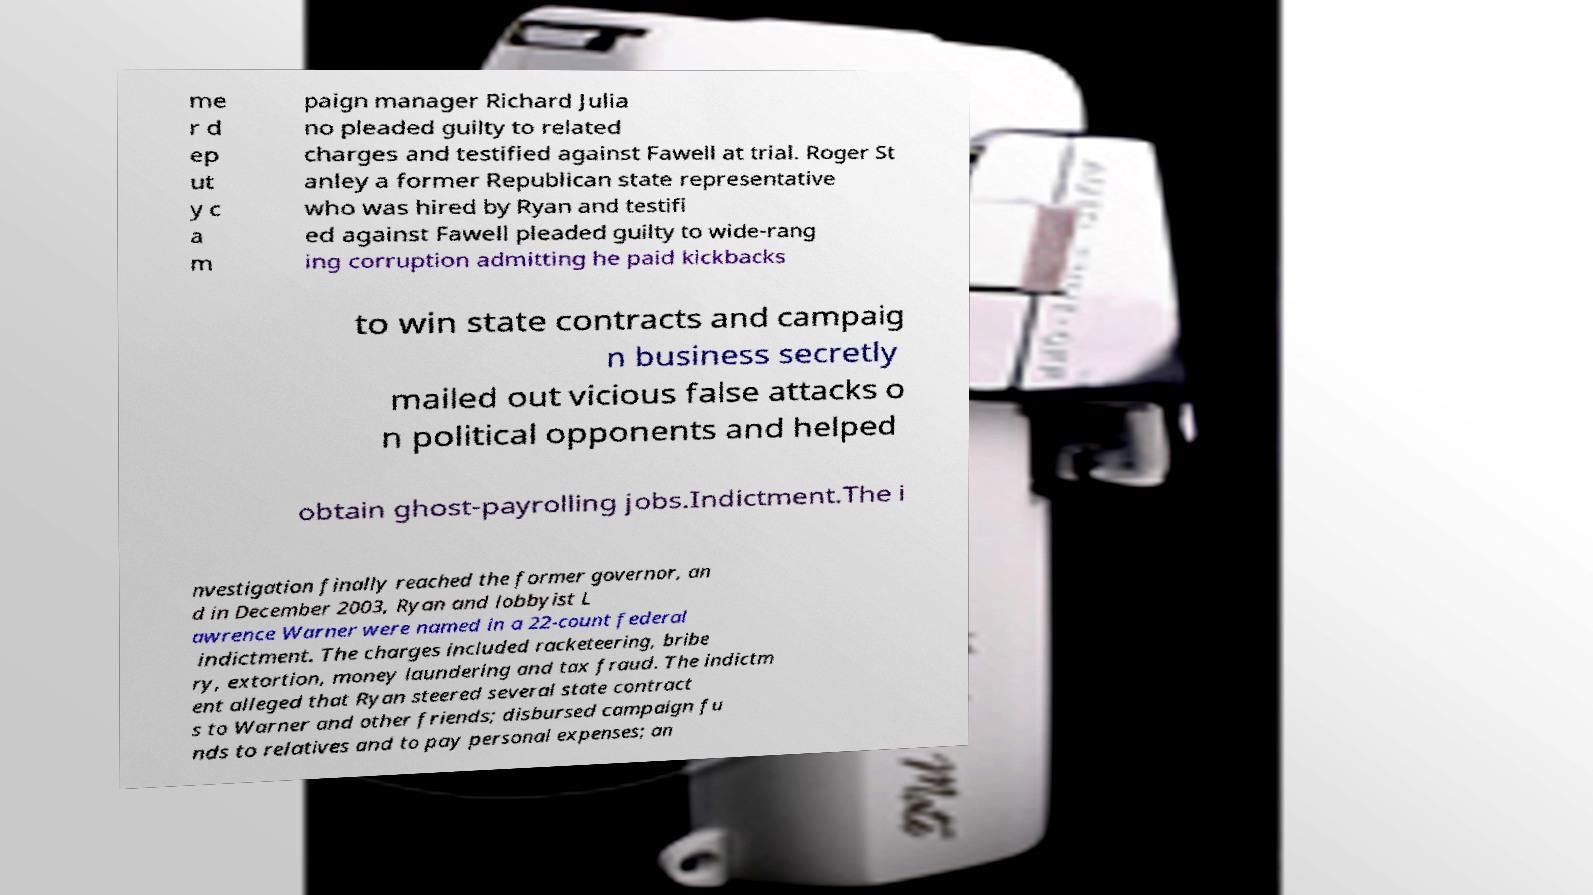Please read and relay the text visible in this image. What does it say? me r d ep ut y c a m paign manager Richard Julia no pleaded guilty to related charges and testified against Fawell at trial. Roger St anley a former Republican state representative who was hired by Ryan and testifi ed against Fawell pleaded guilty to wide-rang ing corruption admitting he paid kickbacks to win state contracts and campaig n business secretly mailed out vicious false attacks o n political opponents and helped obtain ghost-payrolling jobs.Indictment.The i nvestigation finally reached the former governor, an d in December 2003, Ryan and lobbyist L awrence Warner were named in a 22-count federal indictment. The charges included racketeering, bribe ry, extortion, money laundering and tax fraud. The indictm ent alleged that Ryan steered several state contract s to Warner and other friends; disbursed campaign fu nds to relatives and to pay personal expenses; an 